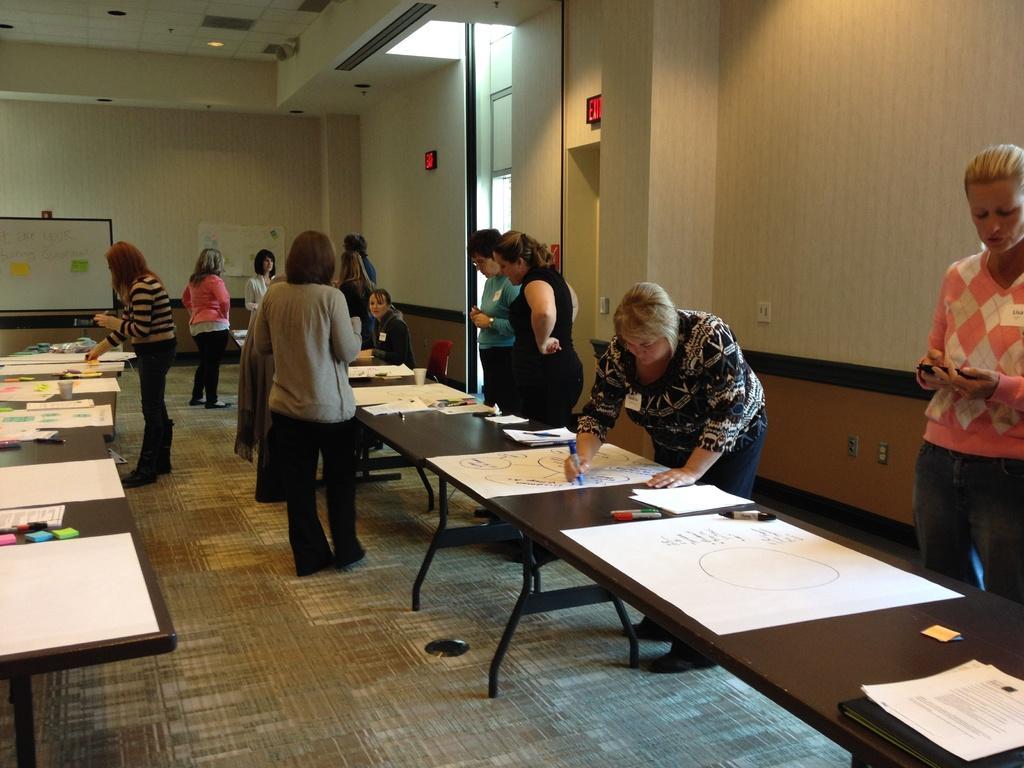Describe this image in one or two sentences. In this image i can see few persons standing and drawing on a chart there is a table there are few pens on the table at the back ground i can see a wall and a board. 